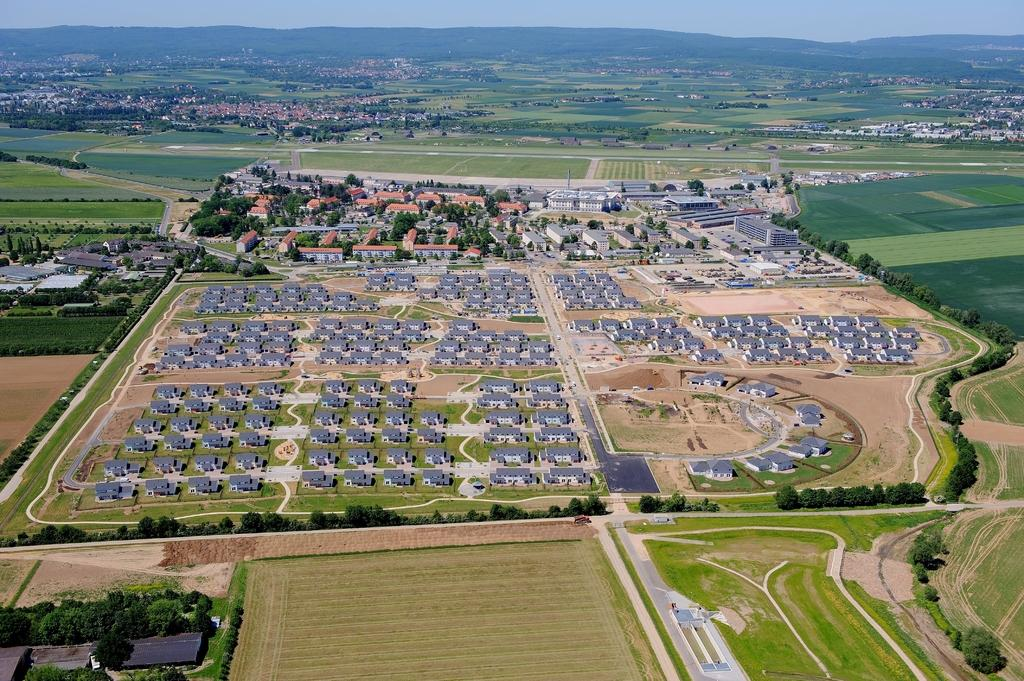What type of structures can be seen in the image? There are buildings in the image. What type of vegetation is present in the image? There are trees in the image. What type of ground cover is present in the image? There is grass in the image. Can you tell me where the maid is giving a haircut in the image? There is no maid or haircut present in the image. What type of rest can be seen in the image? There is no rest or resting activity depicted in the image. 